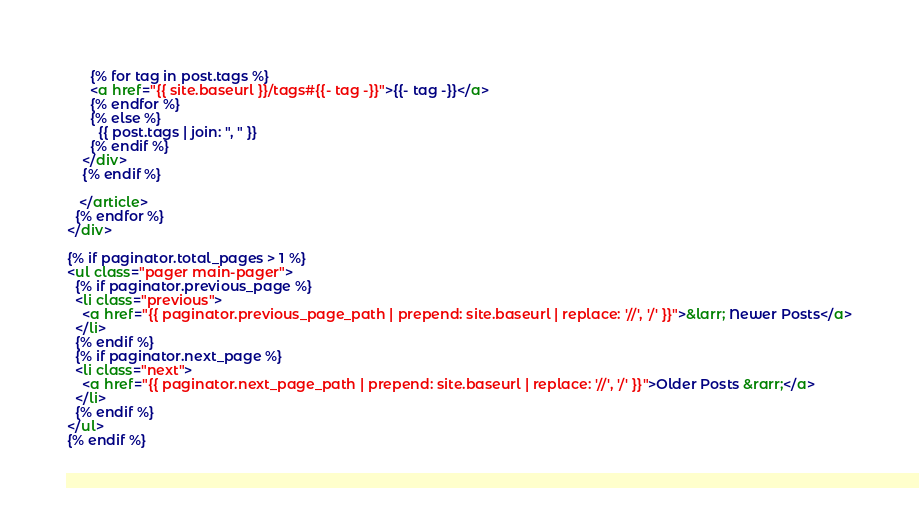Convert code to text. <code><loc_0><loc_0><loc_500><loc_500><_HTML_>      {% for tag in post.tags %}
      <a href="{{ site.baseurl }}/tags#{{- tag -}}">{{- tag -}}</a>
      {% endfor %}
      {% else %}
        {{ post.tags | join: ", " }}
      {% endif %}
    </div>
    {% endif %}

   </article>
  {% endfor %}
</div>

{% if paginator.total_pages > 1 %}
<ul class="pager main-pager">
  {% if paginator.previous_page %}
  <li class="previous">
    <a href="{{ paginator.previous_page_path | prepend: site.baseurl | replace: '//', '/' }}">&larr; Newer Posts</a>
  </li>
  {% endif %}
  {% if paginator.next_page %}
  <li class="next">
    <a href="{{ paginator.next_page_path | prepend: site.baseurl | replace: '//', '/' }}">Older Posts &rarr;</a>
  </li>
  {% endif %}
</ul>
{% endif %}
</code> 